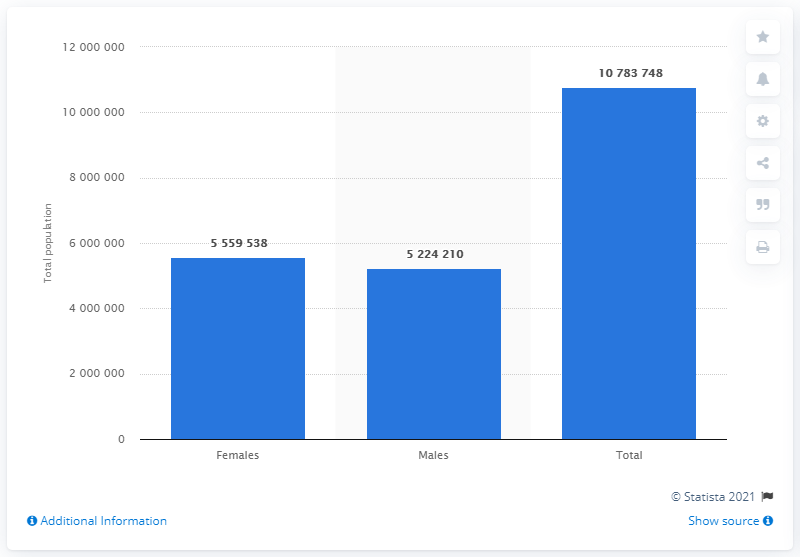Give some essential details in this illustration. In 2016, it is estimated that approximately 107,837,482 people lived in Greece. In 2016, there were approximately 55,595,388 female inhabitants in Greece. 